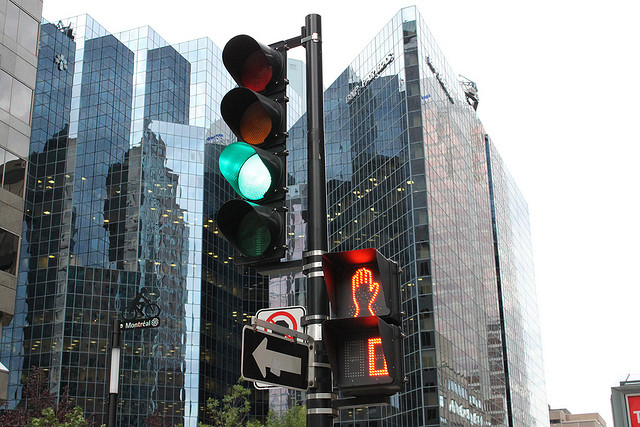How many traffic lights are pictured? 1 